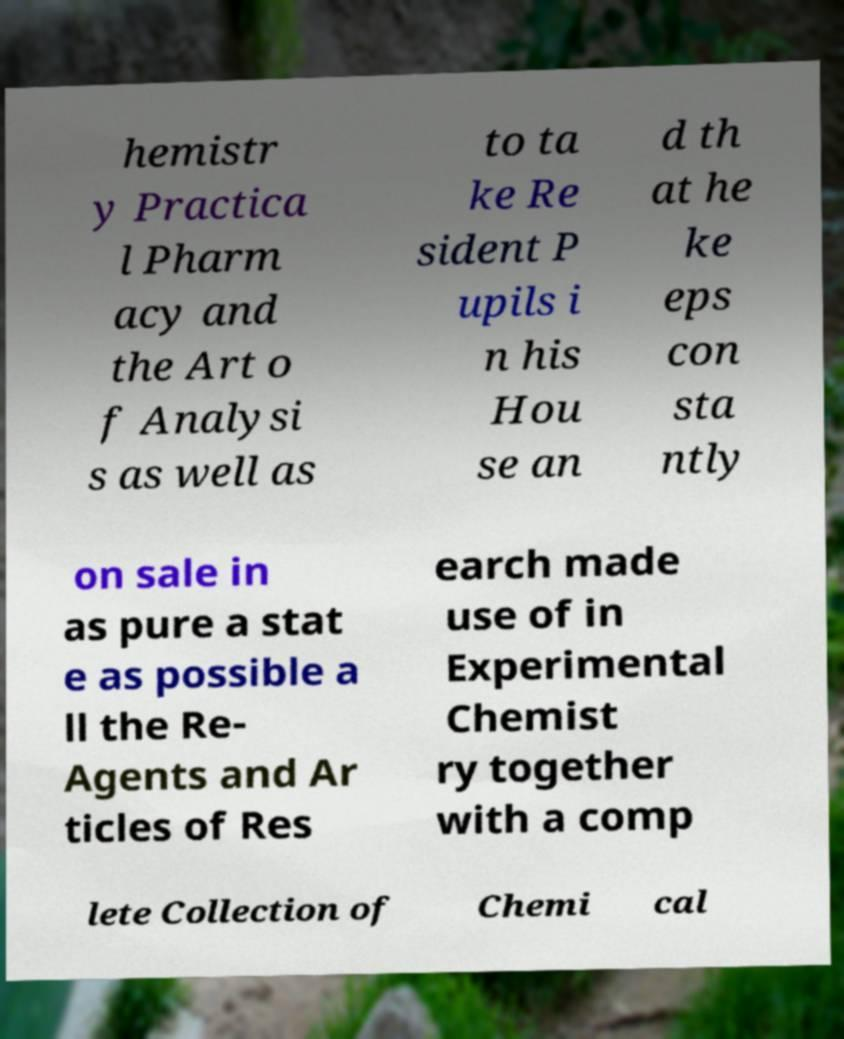What messages or text are displayed in this image? I need them in a readable, typed format. hemistr y Practica l Pharm acy and the Art o f Analysi s as well as to ta ke Re sident P upils i n his Hou se an d th at he ke eps con sta ntly on sale in as pure a stat e as possible a ll the Re- Agents and Ar ticles of Res earch made use of in Experimental Chemist ry together with a comp lete Collection of Chemi cal 